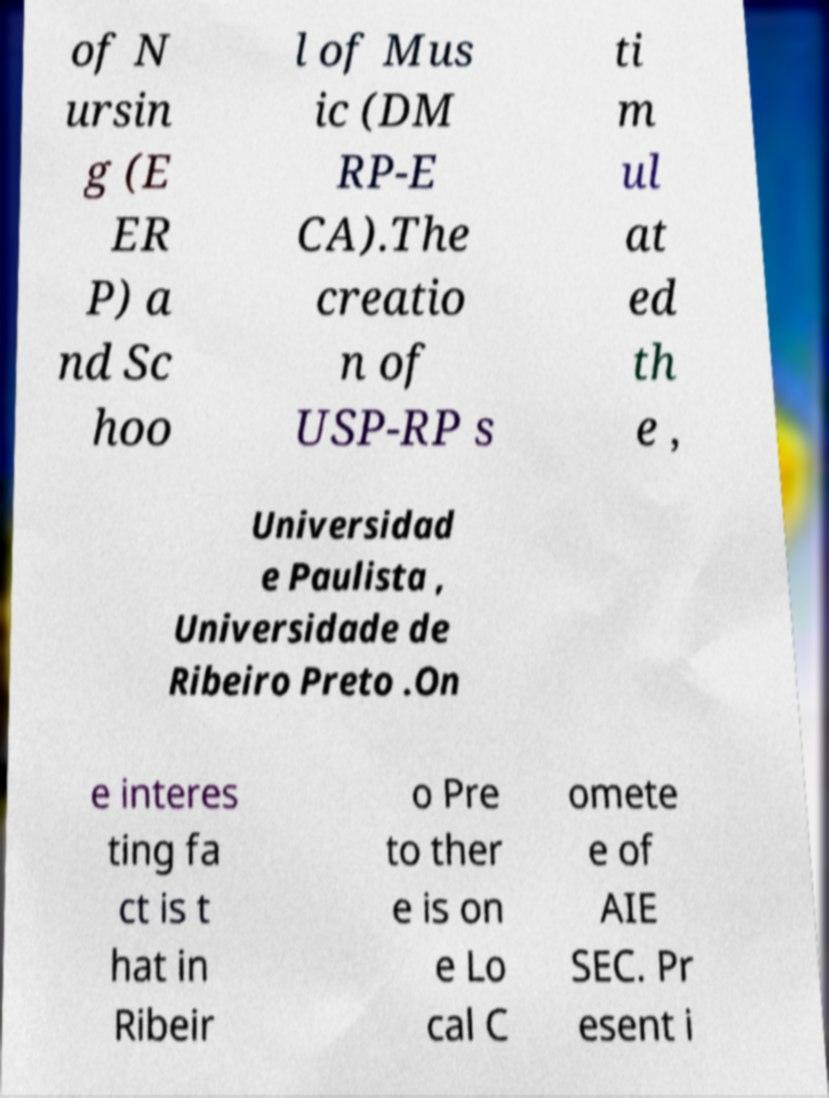Could you extract and type out the text from this image? of N ursin g (E ER P) a nd Sc hoo l of Mus ic (DM RP-E CA).The creatio n of USP-RP s ti m ul at ed th e , Universidad e Paulista , Universidade de Ribeiro Preto .On e interes ting fa ct is t hat in Ribeir o Pre to ther e is on e Lo cal C omete e of AIE SEC. Pr esent i 